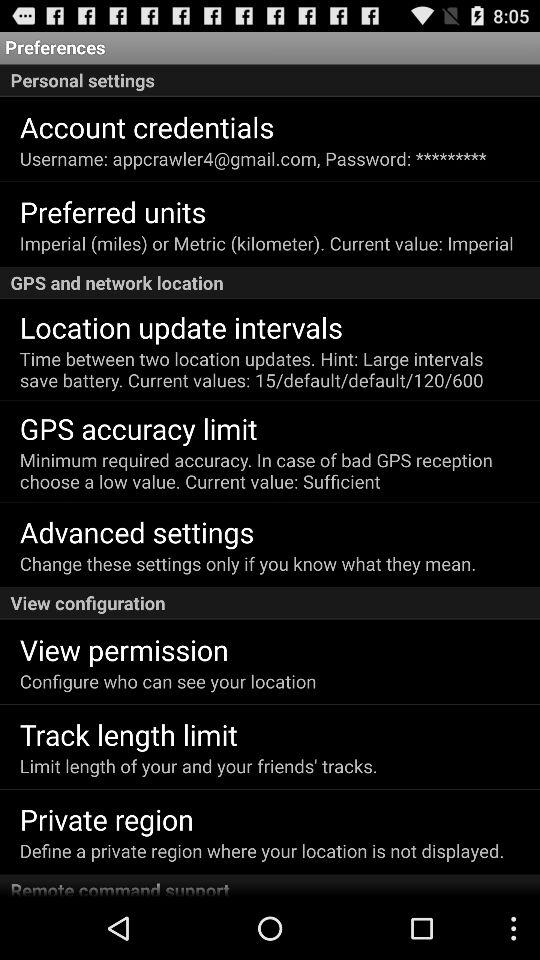What is the description given for the "GPS accuracy limit" setting? The description given for the "GPS accuracy limit" setting is "Minimum required accuracy. In case of bad GPS reception choose a low value". 